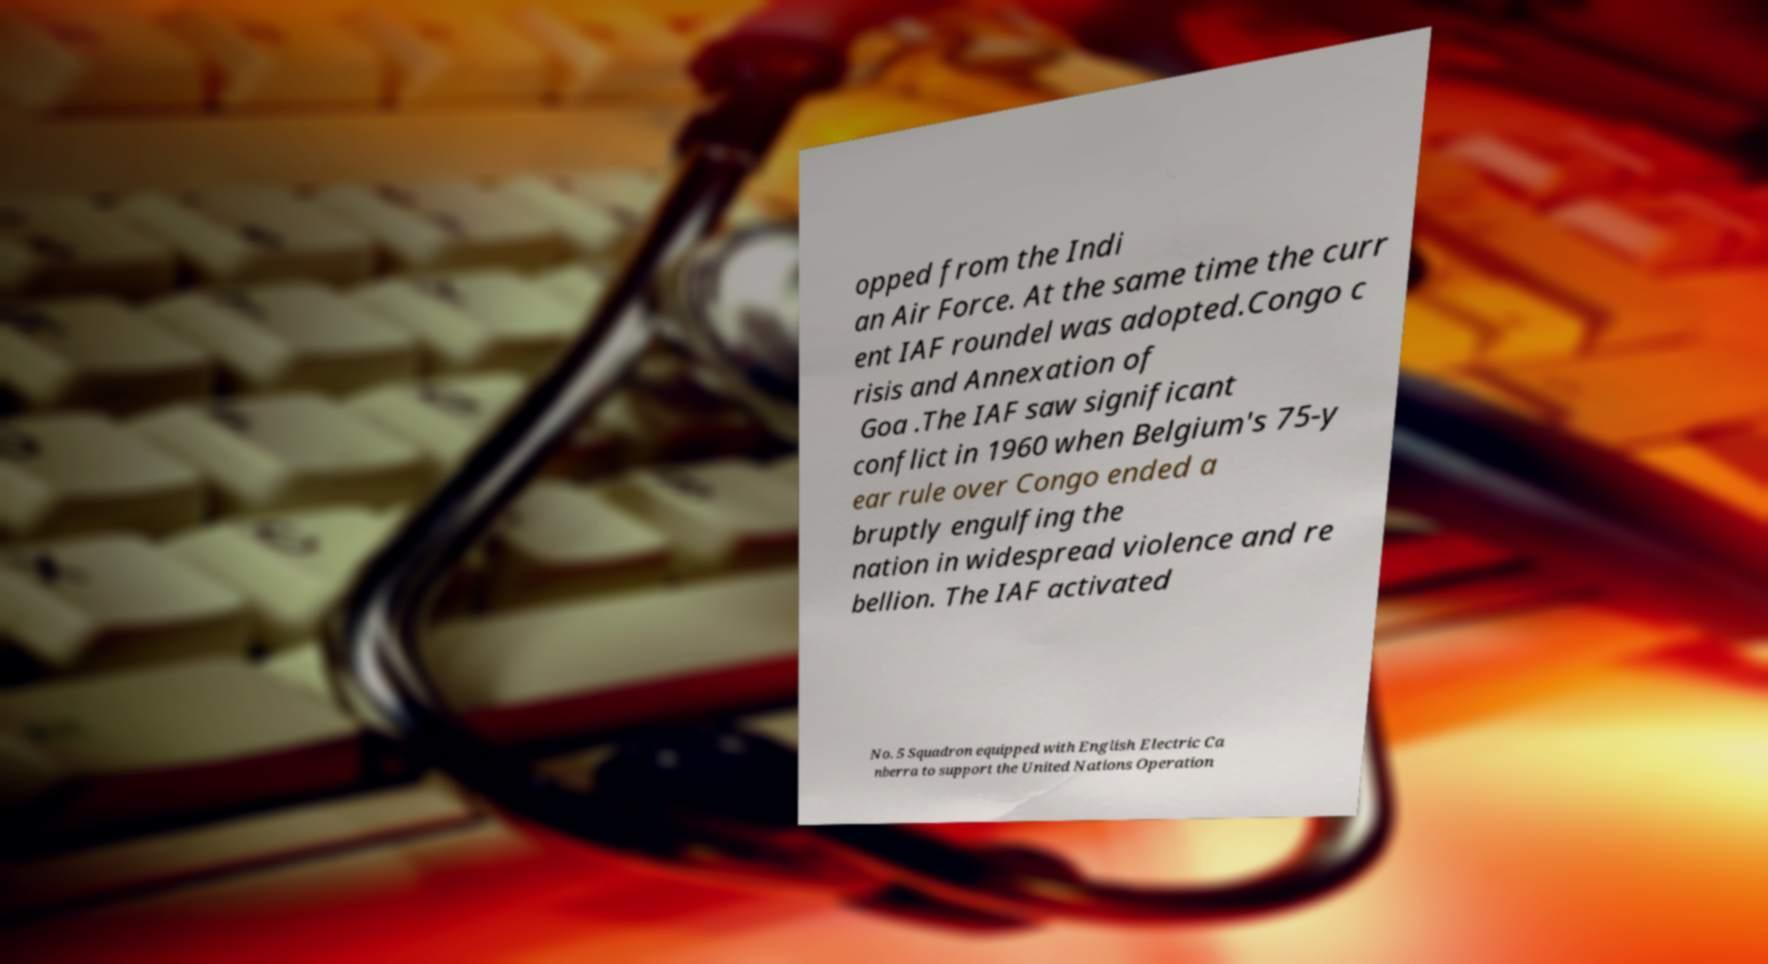Can you read and provide the text displayed in the image?This photo seems to have some interesting text. Can you extract and type it out for me? opped from the Indi an Air Force. At the same time the curr ent IAF roundel was adopted.Congo c risis and Annexation of Goa .The IAF saw significant conflict in 1960 when Belgium's 75-y ear rule over Congo ended a bruptly engulfing the nation in widespread violence and re bellion. The IAF activated No. 5 Squadron equipped with English Electric Ca nberra to support the United Nations Operation 